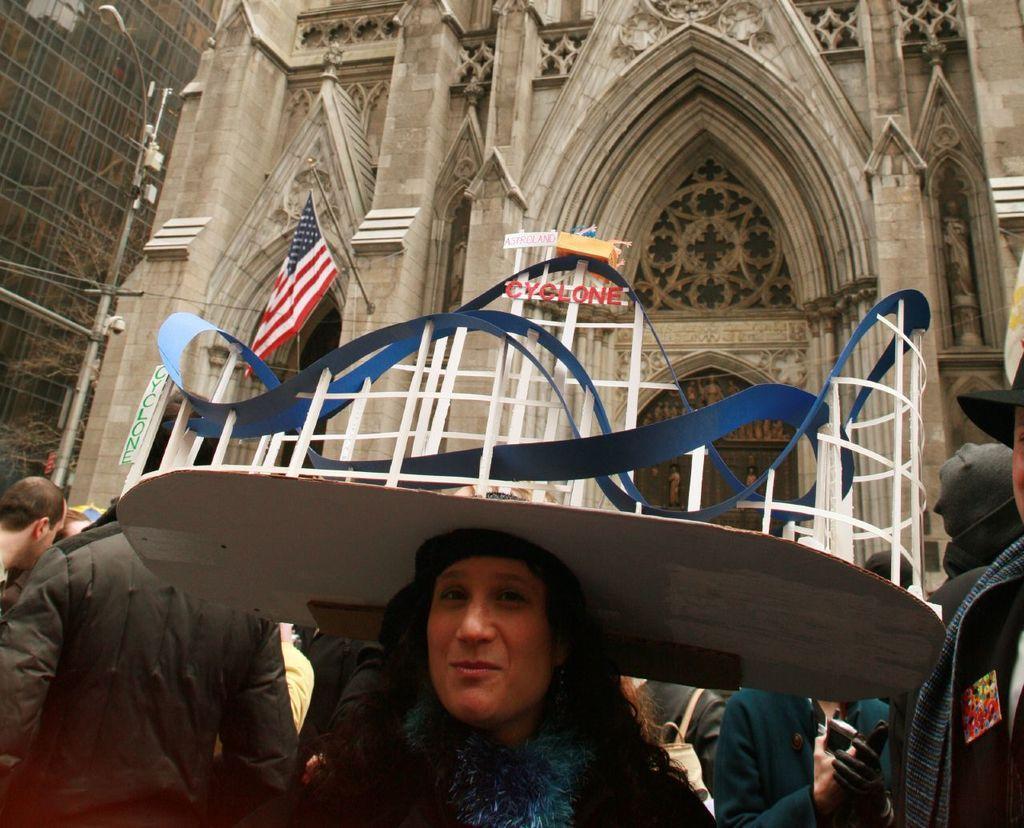Can you describe this image briefly? In this image I can see a woman wearing blue and black colored dress is standing and I can see a white colored object on her head. In the background I can see few other persons standing, few white and blue colored metal rods, a street light pole, a flag and few buildings which are cream in color. 